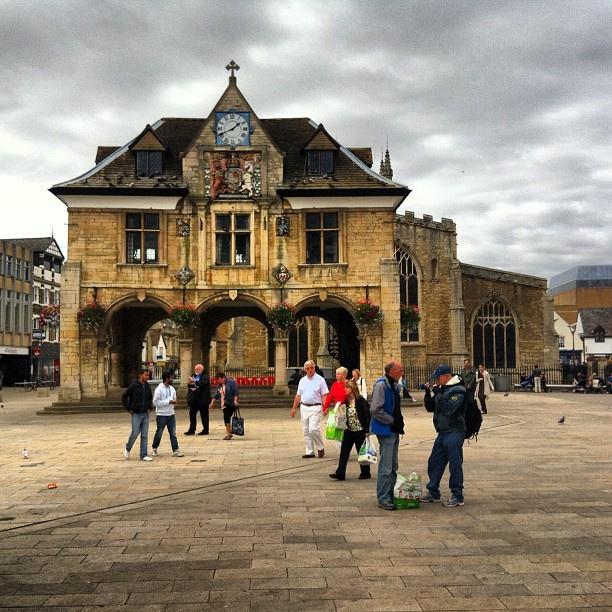What time does the clock say?
Keep it brief. 1:40. What color are the hands and numerals on the clock?
Write a very short answer. Black. How many arch walkways?
Write a very short answer. 3. Are there many people out?
Write a very short answer. No. 